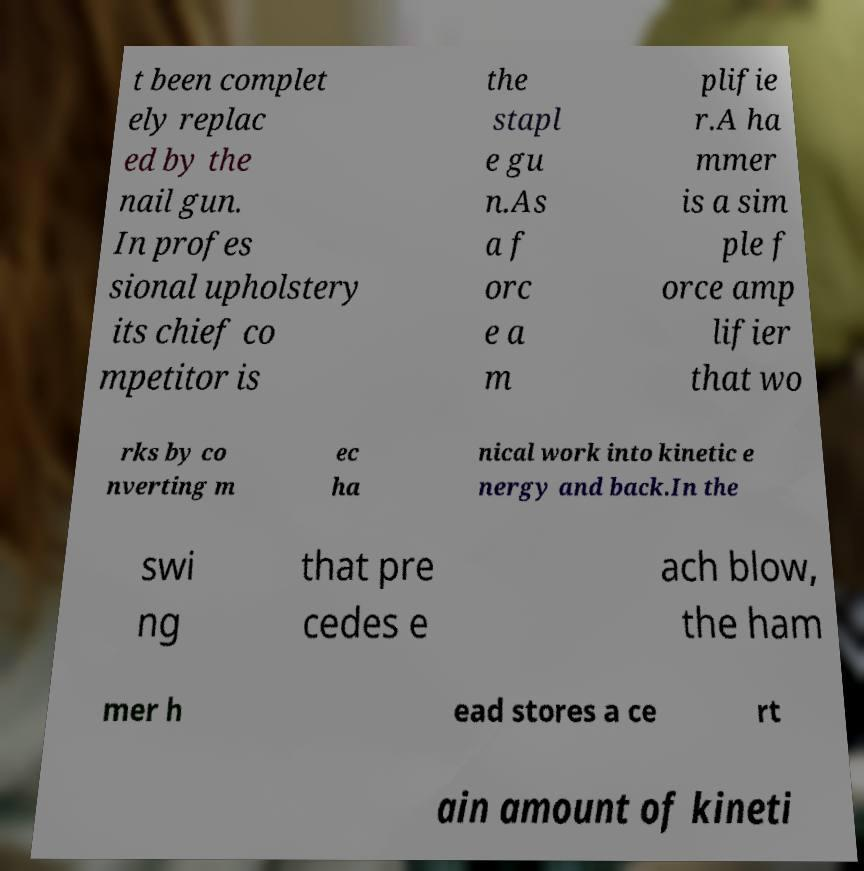Please identify and transcribe the text found in this image. t been complet ely replac ed by the nail gun. In profes sional upholstery its chief co mpetitor is the stapl e gu n.As a f orc e a m plifie r.A ha mmer is a sim ple f orce amp lifier that wo rks by co nverting m ec ha nical work into kinetic e nergy and back.In the swi ng that pre cedes e ach blow, the ham mer h ead stores a ce rt ain amount of kineti 